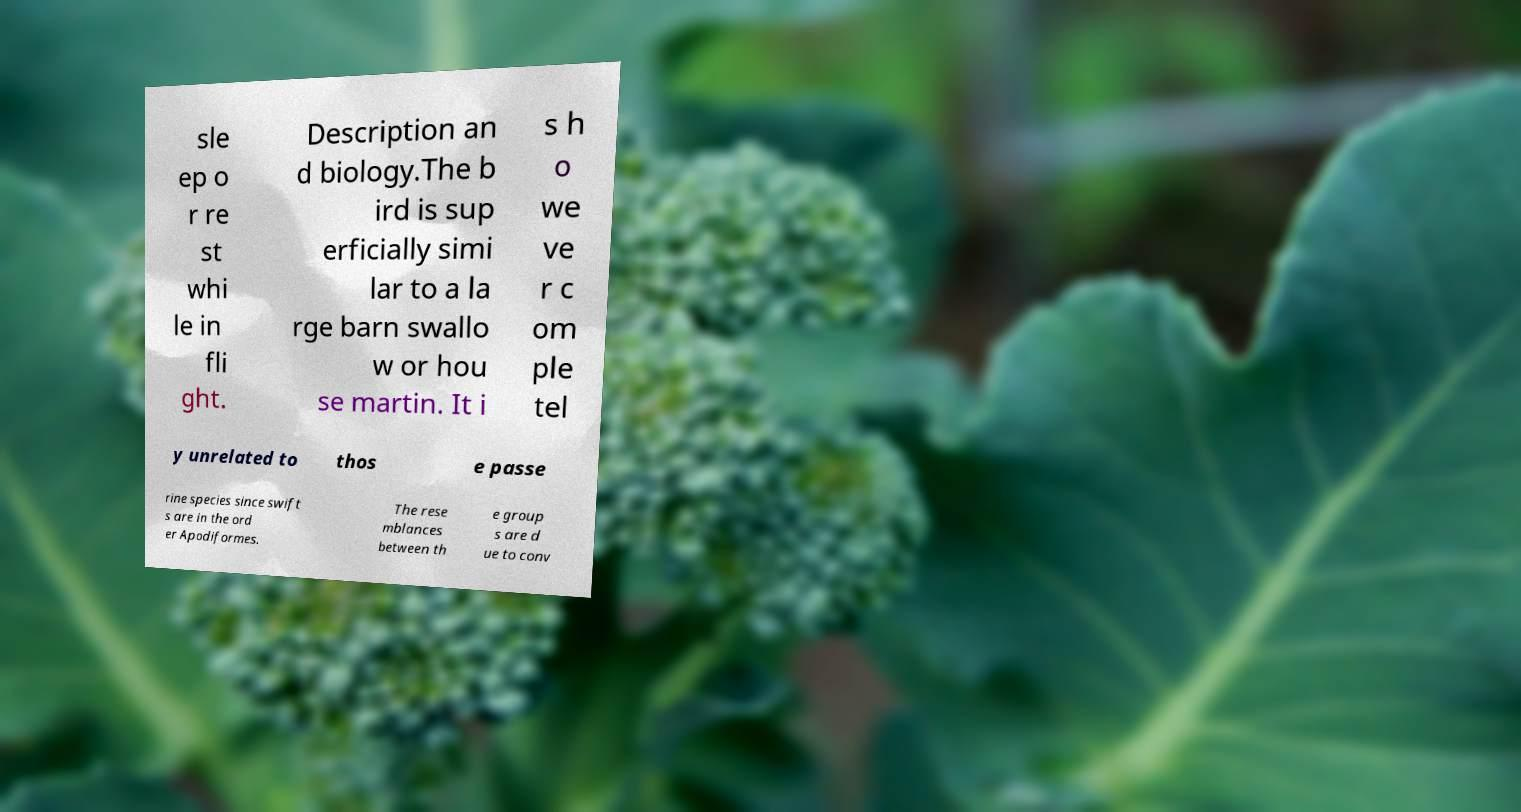I need the written content from this picture converted into text. Can you do that? sle ep o r re st whi le in fli ght. Description an d biology.The b ird is sup erficially simi lar to a la rge barn swallo w or hou se martin. It i s h o we ve r c om ple tel y unrelated to thos e passe rine species since swift s are in the ord er Apodiformes. The rese mblances between th e group s are d ue to conv 